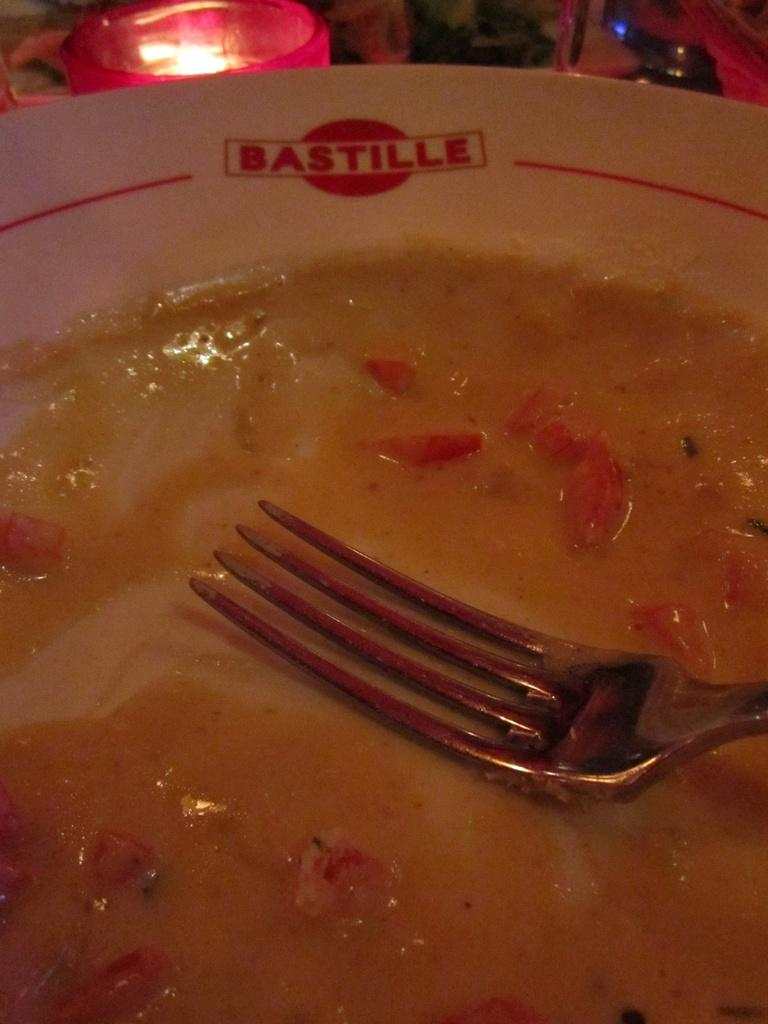What is on the plate that is visible in the image? There are food items on a plate in the image. What utensil is visible in the image? There is a fork visible in the image. What type of books are being suggested by the food items on the plate? There are no books present in the image, and therefore no such suggestion can be made. 